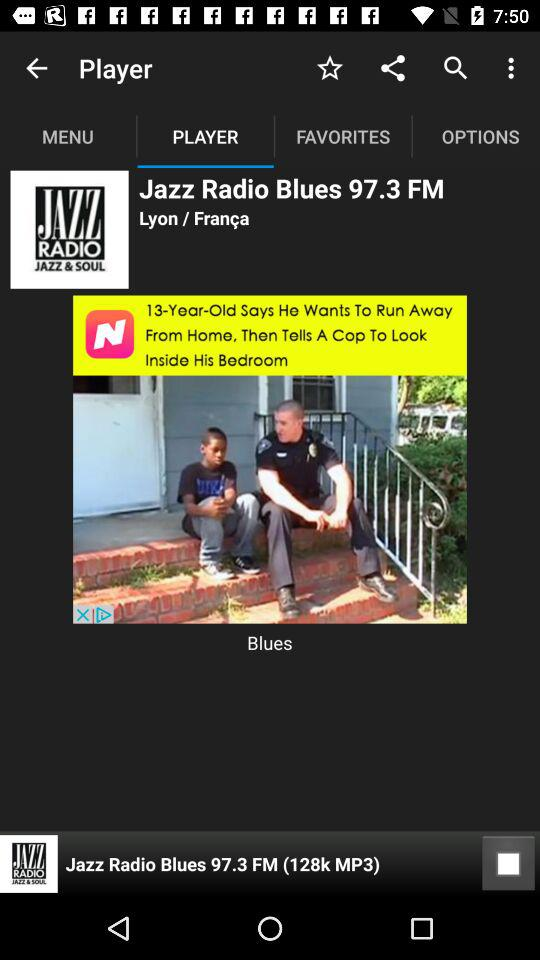What is the size of the mp3 file playing in the player? The size is 128k. 